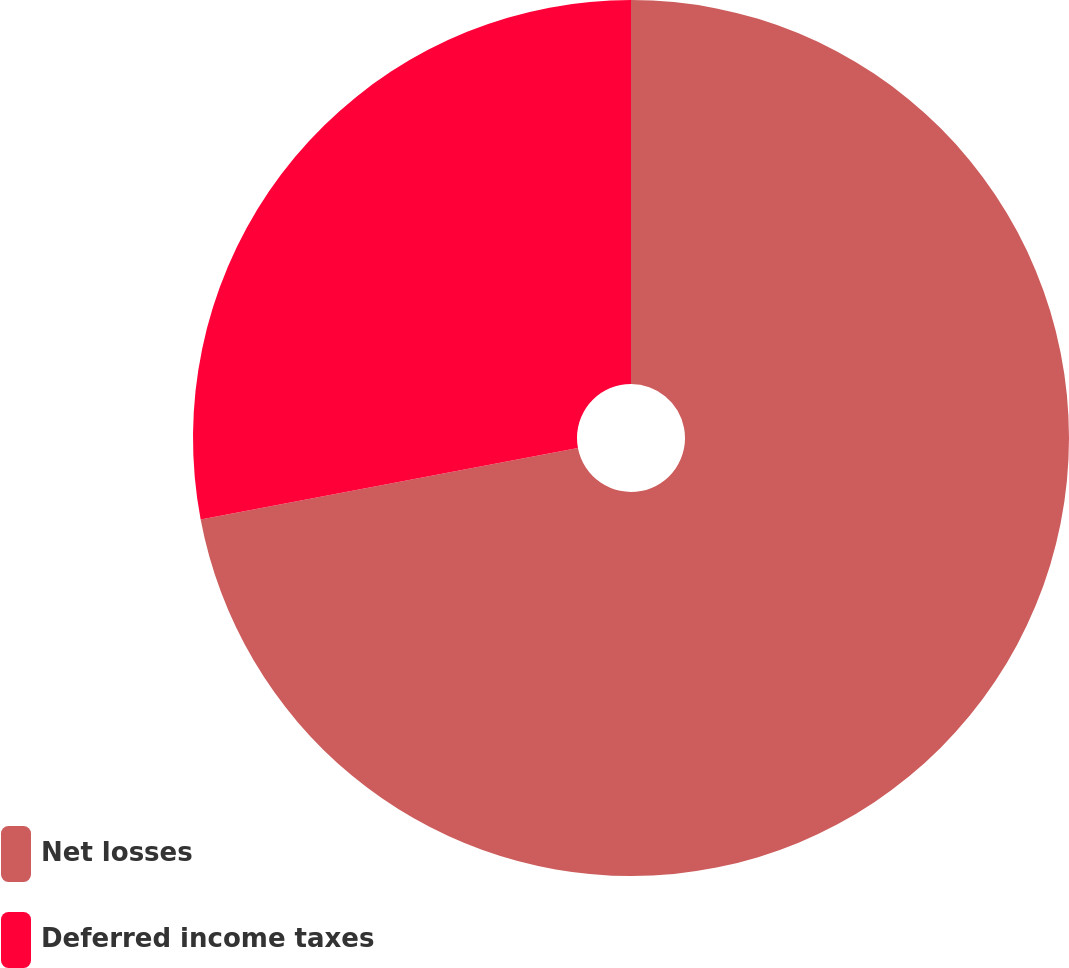Convert chart. <chart><loc_0><loc_0><loc_500><loc_500><pie_chart><fcel>Net losses<fcel>Deferred income taxes<nl><fcel>72.02%<fcel>27.98%<nl></chart> 